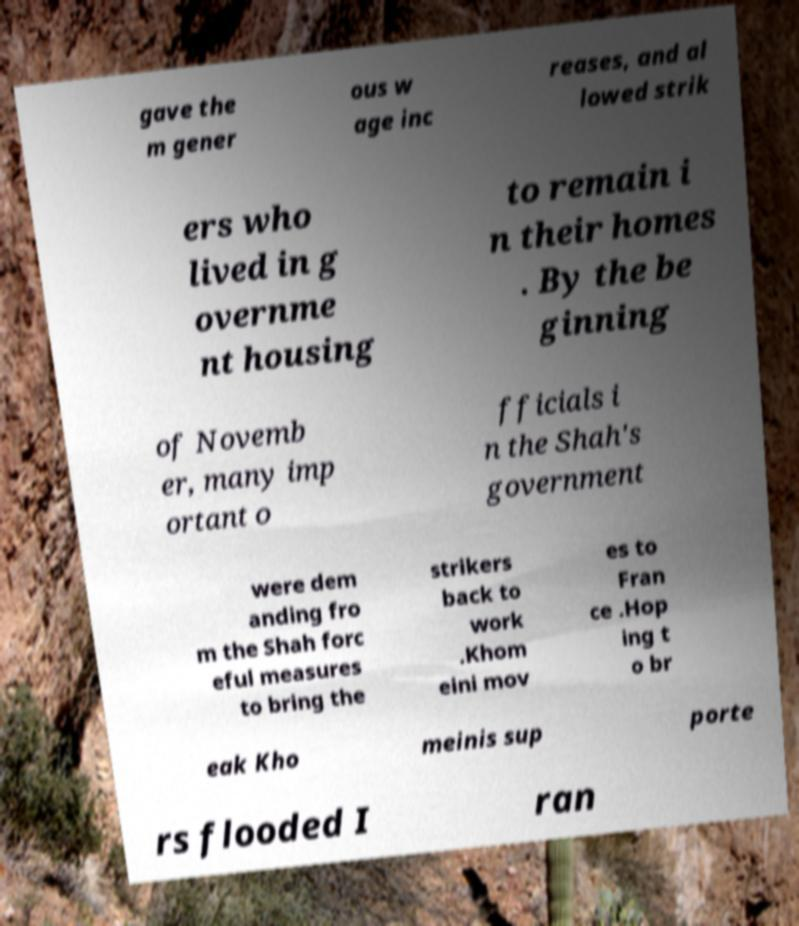Can you read and provide the text displayed in the image?This photo seems to have some interesting text. Can you extract and type it out for me? gave the m gener ous w age inc reases, and al lowed strik ers who lived in g overnme nt housing to remain i n their homes . By the be ginning of Novemb er, many imp ortant o fficials i n the Shah's government were dem anding fro m the Shah forc eful measures to bring the strikers back to work .Khom eini mov es to Fran ce .Hop ing t o br eak Kho meinis sup porte rs flooded I ran 